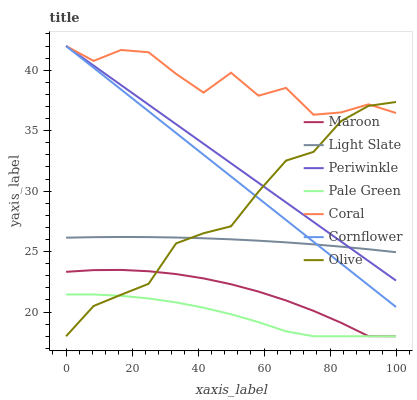Does Pale Green have the minimum area under the curve?
Answer yes or no. Yes. Does Coral have the maximum area under the curve?
Answer yes or no. Yes. Does Light Slate have the minimum area under the curve?
Answer yes or no. No. Does Light Slate have the maximum area under the curve?
Answer yes or no. No. Is Periwinkle the smoothest?
Answer yes or no. Yes. Is Coral the roughest?
Answer yes or no. Yes. Is Light Slate the smoothest?
Answer yes or no. No. Is Light Slate the roughest?
Answer yes or no. No. Does Maroon have the lowest value?
Answer yes or no. Yes. Does Light Slate have the lowest value?
Answer yes or no. No. Does Periwinkle have the highest value?
Answer yes or no. Yes. Does Light Slate have the highest value?
Answer yes or no. No. Is Pale Green less than Cornflower?
Answer yes or no. Yes. Is Coral greater than Maroon?
Answer yes or no. Yes. Does Cornflower intersect Coral?
Answer yes or no. Yes. Is Cornflower less than Coral?
Answer yes or no. No. Is Cornflower greater than Coral?
Answer yes or no. No. Does Pale Green intersect Cornflower?
Answer yes or no. No. 